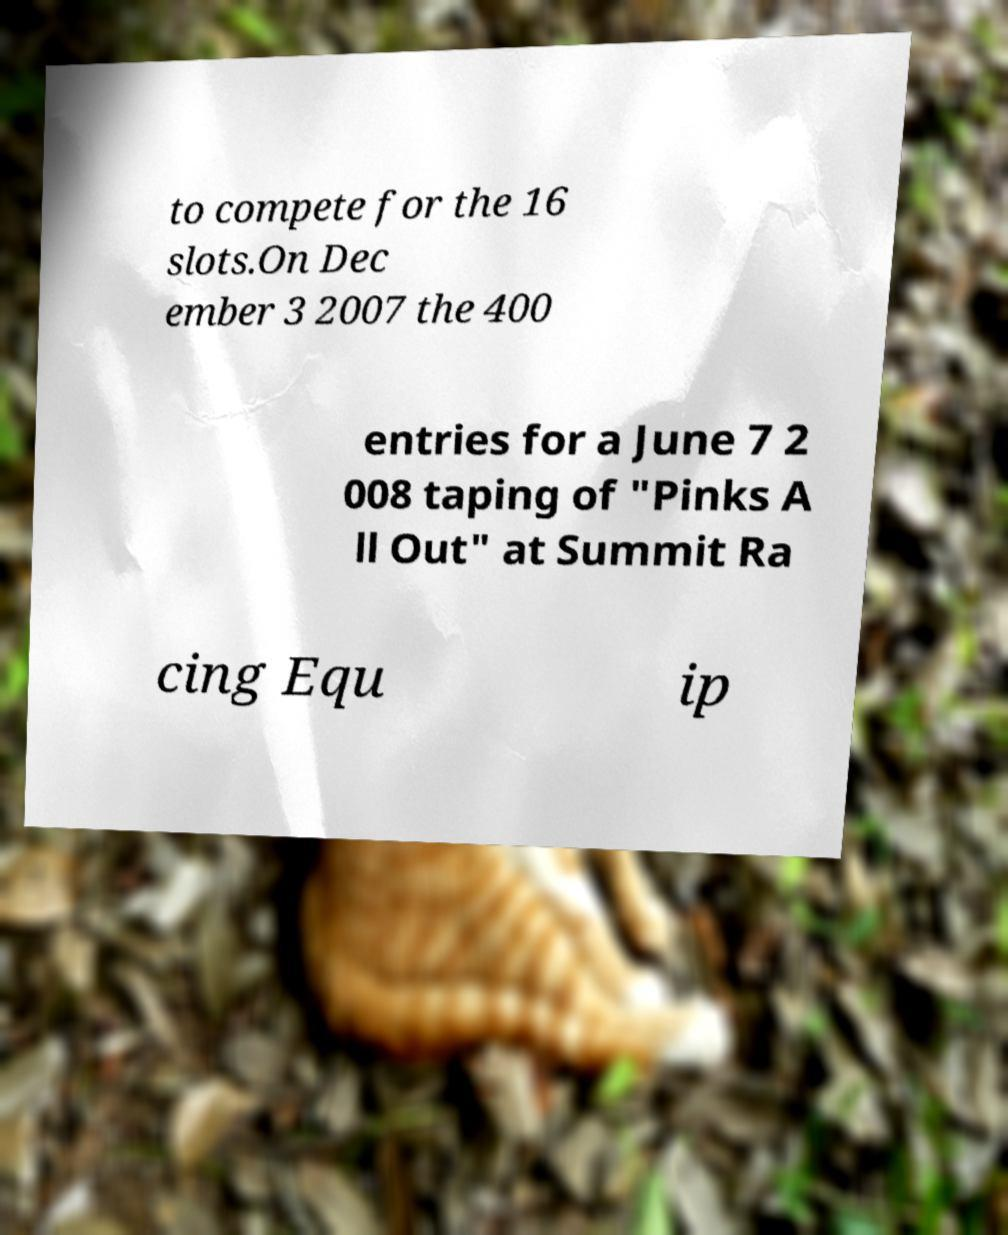Please identify and transcribe the text found in this image. to compete for the 16 slots.On Dec ember 3 2007 the 400 entries for a June 7 2 008 taping of "Pinks A ll Out" at Summit Ra cing Equ ip 